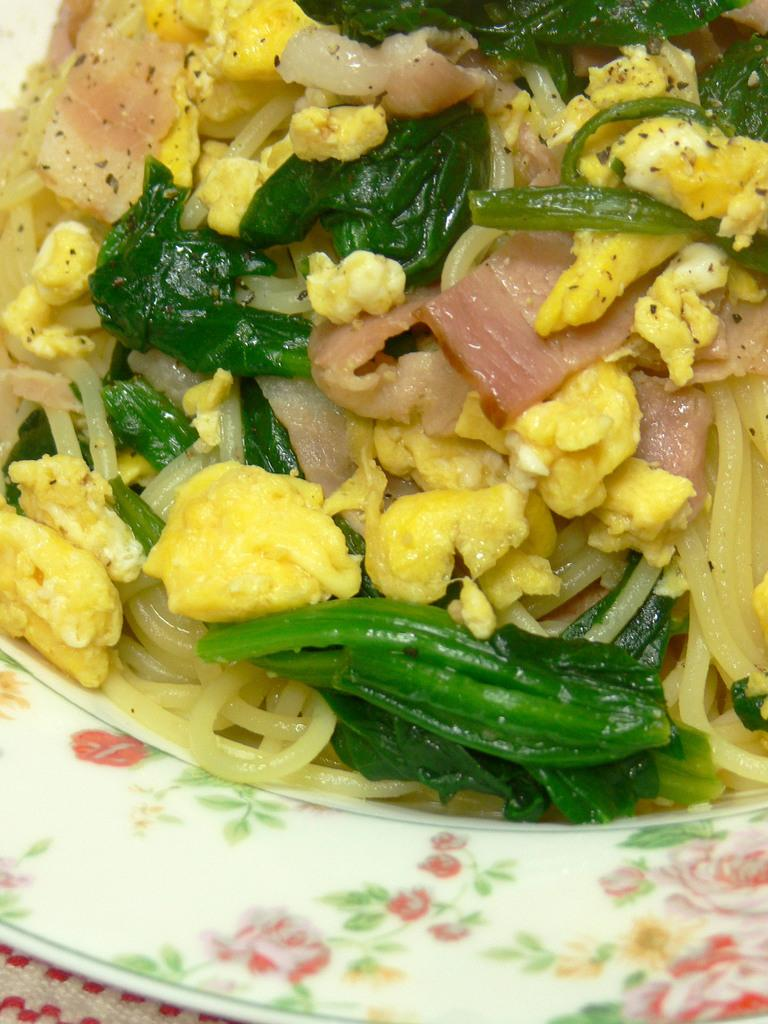What is present in the image related to food? There is food in the image. How is the food presented in the image? The food is on a white color plate. What colors can be seen in the food? The food has yellow and green colors. What else can be observed about the plate in the image? There is a design on the white color plate. Is there a hammer being used to prepare the food in the image? There is no hammer present in the image, and no indication that one is being used to prepare the food. 